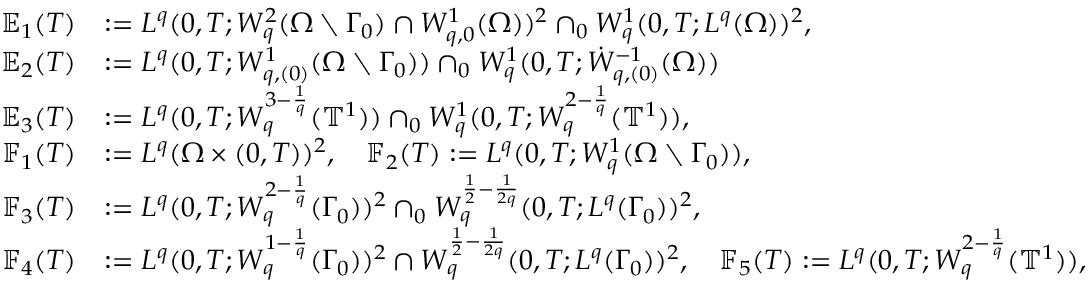Convert formula to latex. <formula><loc_0><loc_0><loc_500><loc_500>\begin{array} { r l } { \mathbb { E } _ { 1 } ( T ) } & { \colon = L ^ { q } ( 0 , T ; W _ { q } ^ { 2 } ( \Omega \ \Gamma _ { 0 } ) \cap W _ { q , 0 } ^ { 1 } ( \Omega ) ) ^ { 2 } \cap _ { 0 } W _ { q } ^ { 1 } ( 0 , T ; L ^ { q } ( \Omega ) ) ^ { 2 } , } \\ { \mathbb { E } _ { 2 } ( T ) } & { \colon = L ^ { q } ( 0 , T ; W _ { q , ( 0 ) } ^ { 1 } ( \Omega \ \Gamma _ { 0 } ) ) \cap _ { 0 } W _ { q } ^ { 1 } ( 0 , T ; \dot { W } _ { q , ( 0 ) } ^ { - 1 } ( \Omega ) ) } \\ { \mathbb { E } _ { 3 } ( T ) } & { \colon = L ^ { q } ( 0 , T ; W _ { q } ^ { 3 - \frac { 1 } { q } } ( { \mathbb { T } } ^ { 1 } ) ) \cap _ { 0 } W _ { q } ^ { 1 } ( 0 , T ; W _ { q } ^ { 2 - \frac { 1 } { q } } ( { \mathbb { T } } ^ { 1 } ) ) , } \\ { \mathbb { F } _ { 1 } ( T ) } & { \colon = L ^ { q } ( \Omega \times ( 0 , T ) ) ^ { 2 } , \quad \mathbb { F } _ { 2 } ( T ) \colon = L ^ { q } ( 0 , T ; W _ { q } ^ { 1 } ( \Omega \ \Gamma _ { 0 } ) ) , } \\ { \mathbb { F } _ { 3 } ( T ) } & { \colon = L ^ { q } ( 0 , T ; W _ { q } ^ { 2 - \frac { 1 } { q } } ( \Gamma _ { 0 } ) ) ^ { 2 } \cap _ { 0 } W _ { q } ^ { \frac { 1 } { 2 } - \frac { 1 } 2 q } } ( 0 , T ; L ^ { q } ( \Gamma _ { 0 } ) ) ^ { 2 } , \quad } \\ { \mathbb { F } _ { 4 } ( T ) } & { \colon = L ^ { q } ( 0 , T ; W _ { q } ^ { 1 - \frac { 1 } { q } } ( \Gamma _ { 0 } ) ) ^ { 2 } \cap W _ { q } ^ { \frac { 1 } { 2 } - \frac { 1 } 2 q } } ( 0 , T ; L ^ { q } ( \Gamma _ { 0 } ) ) ^ { 2 } , \quad \mathbb { F } _ { 5 } ( T ) \colon = L ^ { q } ( 0 , T ; W _ { q } ^ { 2 - \frac { 1 } { q } } ( { \mathbb { T } } ^ { 1 } ) ) , } \end{array}</formula> 